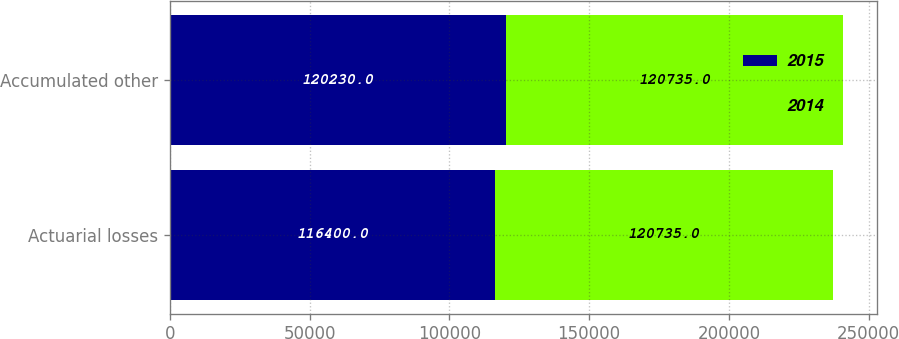Convert chart to OTSL. <chart><loc_0><loc_0><loc_500><loc_500><stacked_bar_chart><ecel><fcel>Actuarial losses<fcel>Accumulated other<nl><fcel>2015<fcel>116400<fcel>120230<nl><fcel>2014<fcel>120735<fcel>120735<nl></chart> 